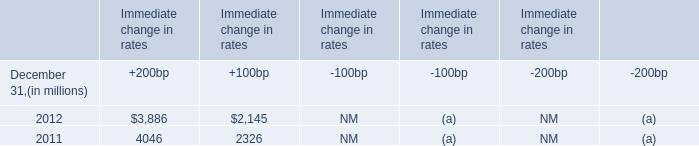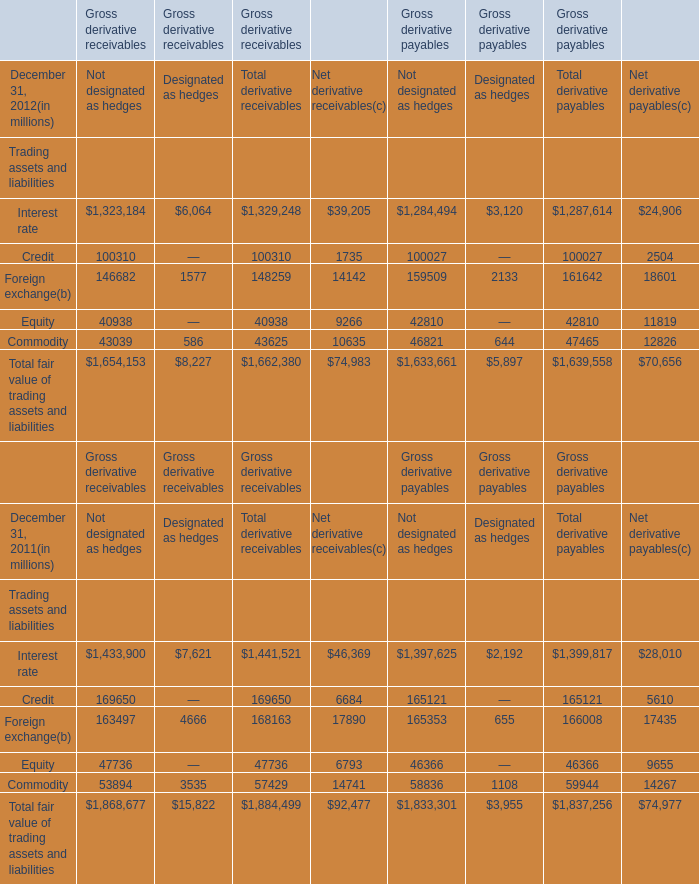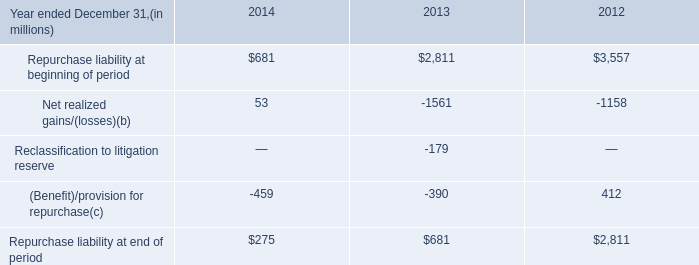what were gross realized gains for 2014 without the make whole settlement netting? 
Computations: (53 + 11)
Answer: 64.0. 